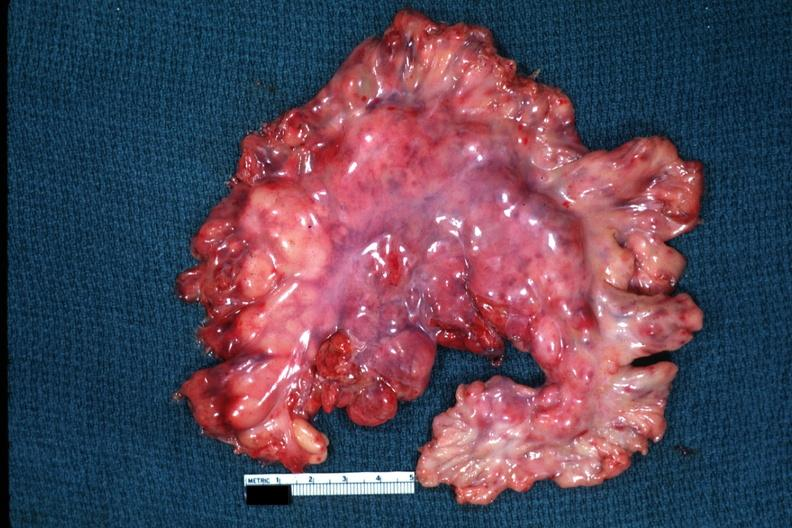s abdomen present?
Answer the question using a single word or phrase. Yes 